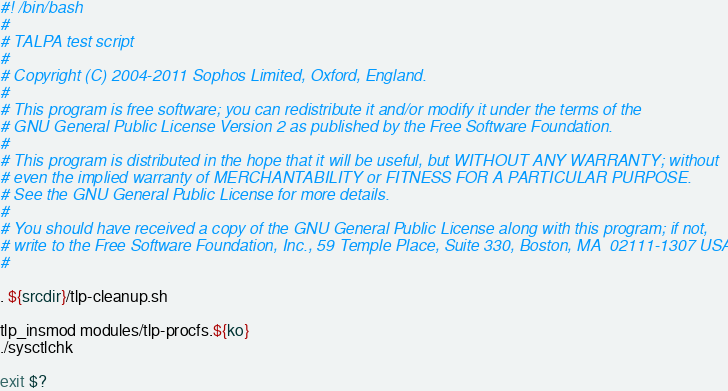<code> <loc_0><loc_0><loc_500><loc_500><_Bash_>#! /bin/bash
#
# TALPA test script
#
# Copyright (C) 2004-2011 Sophos Limited, Oxford, England.
#
# This program is free software; you can redistribute it and/or modify it under the terms of the
# GNU General Public License Version 2 as published by the Free Software Foundation.
#
# This program is distributed in the hope that it will be useful, but WITHOUT ANY WARRANTY; without
# even the implied warranty of MERCHANTABILITY or FITNESS FOR A PARTICULAR PURPOSE.
# See the GNU General Public License for more details.
#
# You should have received a copy of the GNU General Public License along with this program; if not,
# write to the Free Software Foundation, Inc., 59 Temple Place, Suite 330, Boston, MA  02111-1307 USA
#

. ${srcdir}/tlp-cleanup.sh

tlp_insmod modules/tlp-procfs.${ko}
./sysctlchk

exit $?
</code> 